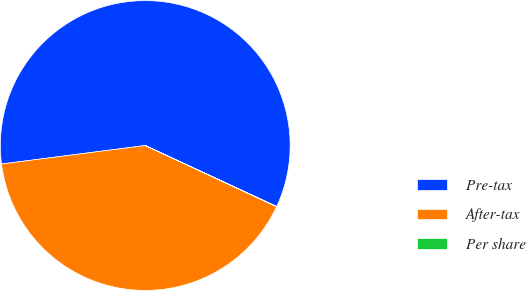<chart> <loc_0><loc_0><loc_500><loc_500><pie_chart><fcel>Pre-tax<fcel>After-tax<fcel>Per share<nl><fcel>58.95%<fcel>41.03%<fcel>0.02%<nl></chart> 